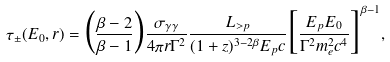<formula> <loc_0><loc_0><loc_500><loc_500>\tau _ { \pm } ( E _ { 0 } , r ) = \Big { ( } \frac { \beta - 2 } { \beta - 1 } \Big { ) } \frac { \sigma _ { \gamma \gamma } } { 4 \pi r \Gamma ^ { 2 } } \frac { L _ { > p } } { ( 1 + z ) ^ { 3 - 2 \beta } E _ { p } c } \Big { [ } \frac { E _ { p } E _ { 0 } } { \Gamma ^ { 2 } m _ { e } ^ { 2 } c ^ { 4 } } \Big { ] } ^ { \beta - 1 } ,</formula> 